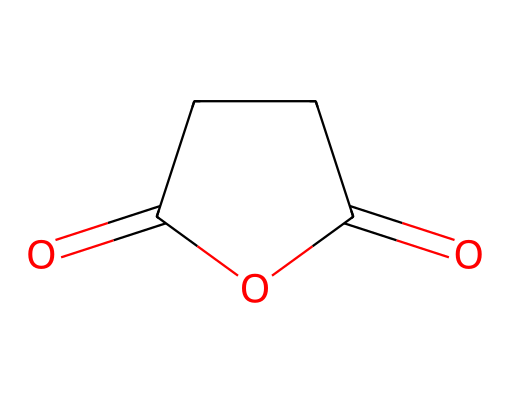What is the molecular formula of this chemical? The structure can be analyzed by counting the atoms of each type present. In succinic anhydride, there are 4 carbon (C) atoms, 4 hydrogen (H) atoms, and 3 oxygen (O) atoms. Therefore, the molecular formula is C4H4O3.
Answer: C4H4O3 How many rings are present in the structure? By examining the structure, the only cycle formed is a five-membered ring due to the bridging of the oxygen atoms and carbon atoms. Hence, there is one ring present.
Answer: 1 What type of functional groups are present in succinic anhydride? The structure exhibits an anhydride functional group, which is characterized by the connection of two acyl groups via an oxygen atom, as well as carbonyl (C=O) groups. Therefore, the functional groups in this compound are anhydride and carbonyl.
Answer: anhydride What is the hybridization of the carbon atoms in the anhydride group? The carbon atoms in the carbonyl (C=O) groups utilize sp2 hybridization as they are involved in double bonds and exhibit trigonal planar geometry around each carbon. Hence, the hybridization for these carbons is sp2.
Answer: sp2 Is this compound polar or nonpolar? The presence of polar carbonyl groups and the overall shape of the molecule leads to a net dipole moment, making the compound polar. Thus, the answer is based on the polar functional groups present in the structure.
Answer: polar Does succinic anhydride undergo hydrolysis in water? Yes, the chemical structure suggests that the anhydride is reactive with water, leading to hydrolysis that forms succinic acid. This reaction is characteristic of acid anhydrides, indicating they readily react with water.
Answer: yes 